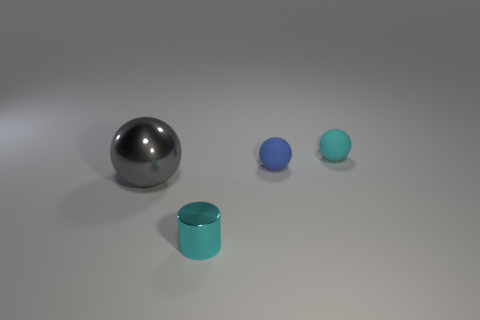Subtract all brown balls. Subtract all green blocks. How many balls are left? 3 Add 1 small blue things. How many objects exist? 5 Subtract all cylinders. How many objects are left? 3 Subtract 0 brown spheres. How many objects are left? 4 Subtract all gray rubber blocks. Subtract all small blue balls. How many objects are left? 3 Add 3 gray metallic spheres. How many gray metallic spheres are left? 4 Add 3 large cyan shiny objects. How many large cyan shiny objects exist? 3 